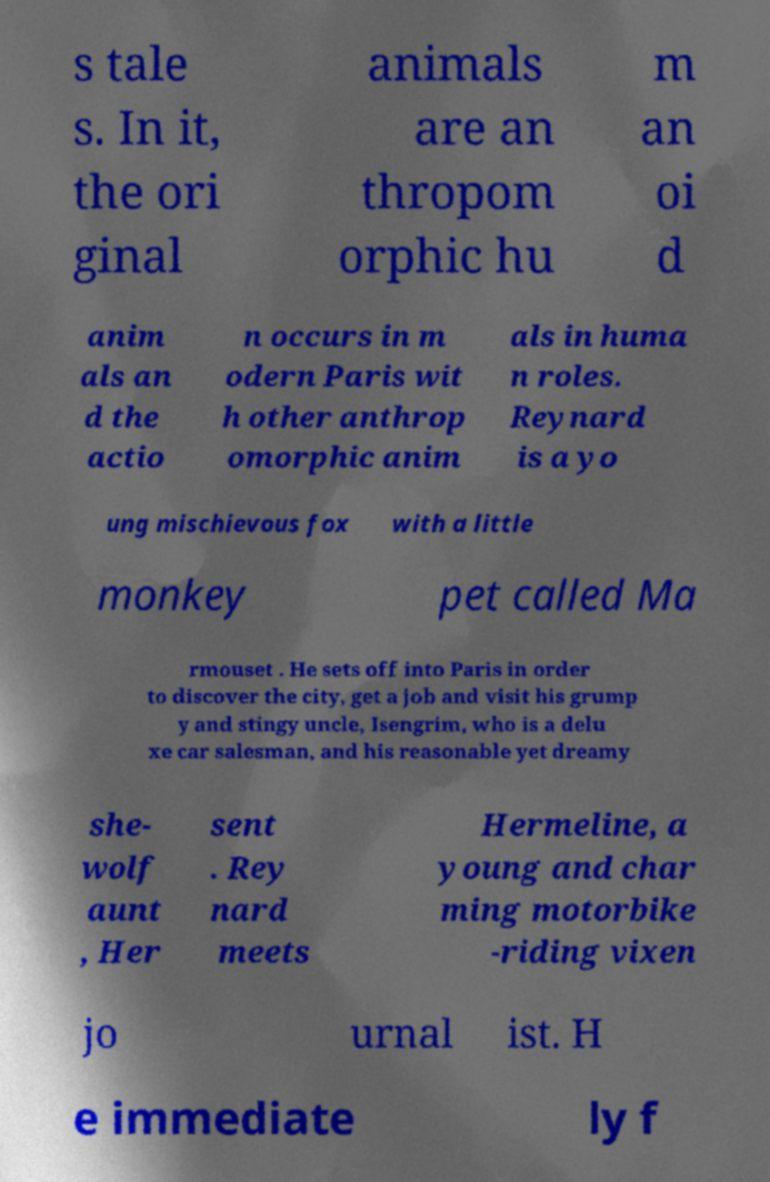Can you accurately transcribe the text from the provided image for me? s tale s. In it, the ori ginal animals are an thropom orphic hu m an oi d anim als an d the actio n occurs in m odern Paris wit h other anthrop omorphic anim als in huma n roles. Reynard is a yo ung mischievous fox with a little monkey pet called Ma rmouset . He sets off into Paris in order to discover the city, get a job and visit his grump y and stingy uncle, Isengrim, who is a delu xe car salesman, and his reasonable yet dreamy she- wolf aunt , Her sent . Rey nard meets Hermeline, a young and char ming motorbike -riding vixen jo urnal ist. H e immediate ly f 